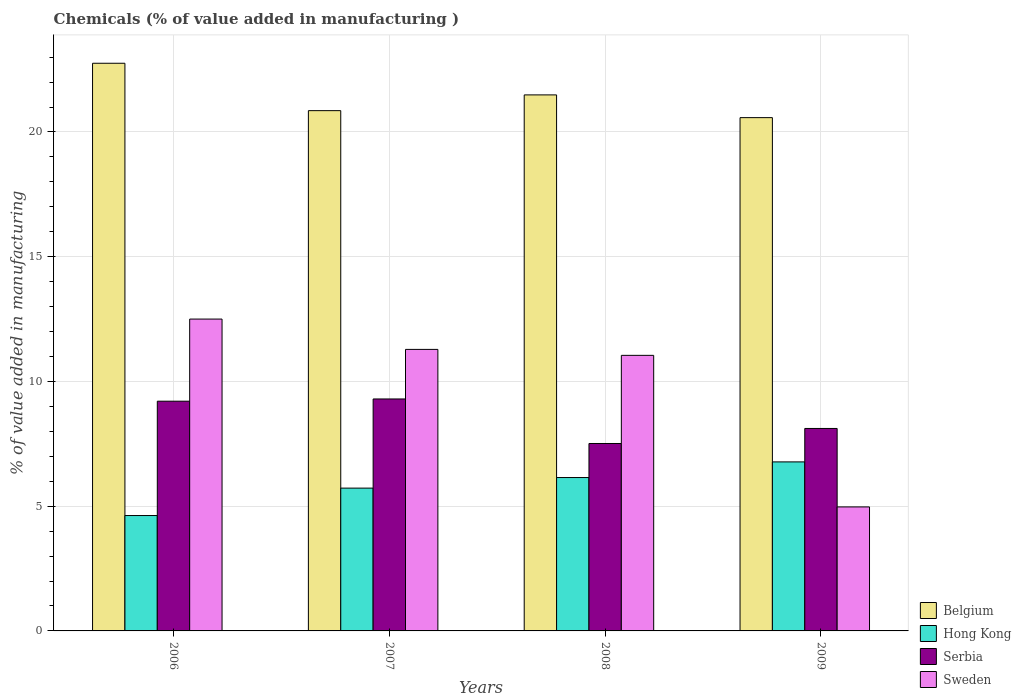How many groups of bars are there?
Provide a short and direct response. 4. Are the number of bars on each tick of the X-axis equal?
Your response must be concise. Yes. How many bars are there on the 4th tick from the left?
Your answer should be compact. 4. How many bars are there on the 2nd tick from the right?
Ensure brevity in your answer.  4. What is the label of the 2nd group of bars from the left?
Provide a succinct answer. 2007. In how many cases, is the number of bars for a given year not equal to the number of legend labels?
Your answer should be compact. 0. What is the value added in manufacturing chemicals in Sweden in 2007?
Your answer should be compact. 11.29. Across all years, what is the maximum value added in manufacturing chemicals in Sweden?
Offer a very short reply. 12.5. Across all years, what is the minimum value added in manufacturing chemicals in Belgium?
Keep it short and to the point. 20.58. In which year was the value added in manufacturing chemicals in Belgium maximum?
Keep it short and to the point. 2006. In which year was the value added in manufacturing chemicals in Serbia minimum?
Provide a short and direct response. 2008. What is the total value added in manufacturing chemicals in Sweden in the graph?
Give a very brief answer. 39.8. What is the difference between the value added in manufacturing chemicals in Sweden in 2006 and that in 2007?
Your response must be concise. 1.22. What is the difference between the value added in manufacturing chemicals in Hong Kong in 2007 and the value added in manufacturing chemicals in Serbia in 2009?
Your response must be concise. -2.39. What is the average value added in manufacturing chemicals in Sweden per year?
Your answer should be very brief. 9.95. In the year 2009, what is the difference between the value added in manufacturing chemicals in Serbia and value added in manufacturing chemicals in Sweden?
Your answer should be very brief. 3.14. In how many years, is the value added in manufacturing chemicals in Belgium greater than 10 %?
Offer a terse response. 4. What is the ratio of the value added in manufacturing chemicals in Hong Kong in 2006 to that in 2009?
Make the answer very short. 0.68. Is the value added in manufacturing chemicals in Serbia in 2006 less than that in 2008?
Your answer should be compact. No. Is the difference between the value added in manufacturing chemicals in Serbia in 2006 and 2009 greater than the difference between the value added in manufacturing chemicals in Sweden in 2006 and 2009?
Offer a very short reply. No. What is the difference between the highest and the second highest value added in manufacturing chemicals in Serbia?
Your answer should be compact. 0.09. What is the difference between the highest and the lowest value added in manufacturing chemicals in Belgium?
Offer a terse response. 2.18. Is the sum of the value added in manufacturing chemicals in Serbia in 2006 and 2008 greater than the maximum value added in manufacturing chemicals in Hong Kong across all years?
Keep it short and to the point. Yes. Is it the case that in every year, the sum of the value added in manufacturing chemicals in Serbia and value added in manufacturing chemicals in Sweden is greater than the sum of value added in manufacturing chemicals in Hong Kong and value added in manufacturing chemicals in Belgium?
Your answer should be compact. No. What does the 3rd bar from the left in 2009 represents?
Your response must be concise. Serbia. What does the 3rd bar from the right in 2009 represents?
Provide a short and direct response. Hong Kong. How many bars are there?
Make the answer very short. 16. What is the difference between two consecutive major ticks on the Y-axis?
Give a very brief answer. 5. Are the values on the major ticks of Y-axis written in scientific E-notation?
Make the answer very short. No. How are the legend labels stacked?
Offer a very short reply. Vertical. What is the title of the graph?
Your response must be concise. Chemicals (% of value added in manufacturing ). Does "Kenya" appear as one of the legend labels in the graph?
Provide a short and direct response. No. What is the label or title of the Y-axis?
Your answer should be very brief. % of value added in manufacturing. What is the % of value added in manufacturing in Belgium in 2006?
Offer a terse response. 22.76. What is the % of value added in manufacturing of Hong Kong in 2006?
Offer a very short reply. 4.63. What is the % of value added in manufacturing in Serbia in 2006?
Your response must be concise. 9.21. What is the % of value added in manufacturing in Sweden in 2006?
Your response must be concise. 12.5. What is the % of value added in manufacturing in Belgium in 2007?
Keep it short and to the point. 20.86. What is the % of value added in manufacturing of Hong Kong in 2007?
Give a very brief answer. 5.72. What is the % of value added in manufacturing in Serbia in 2007?
Provide a short and direct response. 9.3. What is the % of value added in manufacturing of Sweden in 2007?
Provide a succinct answer. 11.29. What is the % of value added in manufacturing of Belgium in 2008?
Provide a short and direct response. 21.49. What is the % of value added in manufacturing in Hong Kong in 2008?
Offer a very short reply. 6.15. What is the % of value added in manufacturing of Serbia in 2008?
Offer a terse response. 7.51. What is the % of value added in manufacturing of Sweden in 2008?
Your response must be concise. 11.05. What is the % of value added in manufacturing in Belgium in 2009?
Give a very brief answer. 20.58. What is the % of value added in manufacturing of Hong Kong in 2009?
Ensure brevity in your answer.  6.78. What is the % of value added in manufacturing of Serbia in 2009?
Offer a terse response. 8.12. What is the % of value added in manufacturing in Sweden in 2009?
Make the answer very short. 4.97. Across all years, what is the maximum % of value added in manufacturing in Belgium?
Provide a succinct answer. 22.76. Across all years, what is the maximum % of value added in manufacturing of Hong Kong?
Offer a very short reply. 6.78. Across all years, what is the maximum % of value added in manufacturing in Serbia?
Provide a short and direct response. 9.3. Across all years, what is the maximum % of value added in manufacturing in Sweden?
Give a very brief answer. 12.5. Across all years, what is the minimum % of value added in manufacturing of Belgium?
Provide a succinct answer. 20.58. Across all years, what is the minimum % of value added in manufacturing in Hong Kong?
Your answer should be compact. 4.63. Across all years, what is the minimum % of value added in manufacturing of Serbia?
Your answer should be compact. 7.51. Across all years, what is the minimum % of value added in manufacturing of Sweden?
Your answer should be very brief. 4.97. What is the total % of value added in manufacturing of Belgium in the graph?
Your response must be concise. 85.67. What is the total % of value added in manufacturing in Hong Kong in the graph?
Provide a succinct answer. 23.27. What is the total % of value added in manufacturing in Serbia in the graph?
Give a very brief answer. 34.14. What is the total % of value added in manufacturing in Sweden in the graph?
Keep it short and to the point. 39.8. What is the difference between the % of value added in manufacturing in Belgium in 2006 and that in 2007?
Ensure brevity in your answer.  1.9. What is the difference between the % of value added in manufacturing in Hong Kong in 2006 and that in 2007?
Make the answer very short. -1.1. What is the difference between the % of value added in manufacturing in Serbia in 2006 and that in 2007?
Make the answer very short. -0.09. What is the difference between the % of value added in manufacturing of Sweden in 2006 and that in 2007?
Provide a succinct answer. 1.22. What is the difference between the % of value added in manufacturing of Belgium in 2006 and that in 2008?
Keep it short and to the point. 1.27. What is the difference between the % of value added in manufacturing in Hong Kong in 2006 and that in 2008?
Keep it short and to the point. -1.52. What is the difference between the % of value added in manufacturing of Serbia in 2006 and that in 2008?
Keep it short and to the point. 1.7. What is the difference between the % of value added in manufacturing of Sweden in 2006 and that in 2008?
Keep it short and to the point. 1.45. What is the difference between the % of value added in manufacturing in Belgium in 2006 and that in 2009?
Offer a very short reply. 2.18. What is the difference between the % of value added in manufacturing of Hong Kong in 2006 and that in 2009?
Your response must be concise. -2.15. What is the difference between the % of value added in manufacturing in Serbia in 2006 and that in 2009?
Give a very brief answer. 1.09. What is the difference between the % of value added in manufacturing of Sweden in 2006 and that in 2009?
Ensure brevity in your answer.  7.53. What is the difference between the % of value added in manufacturing in Belgium in 2007 and that in 2008?
Provide a short and direct response. -0.63. What is the difference between the % of value added in manufacturing in Hong Kong in 2007 and that in 2008?
Offer a very short reply. -0.42. What is the difference between the % of value added in manufacturing of Serbia in 2007 and that in 2008?
Provide a short and direct response. 1.78. What is the difference between the % of value added in manufacturing in Sweden in 2007 and that in 2008?
Keep it short and to the point. 0.24. What is the difference between the % of value added in manufacturing in Belgium in 2007 and that in 2009?
Your response must be concise. 0.28. What is the difference between the % of value added in manufacturing of Hong Kong in 2007 and that in 2009?
Your response must be concise. -1.05. What is the difference between the % of value added in manufacturing in Serbia in 2007 and that in 2009?
Provide a succinct answer. 1.18. What is the difference between the % of value added in manufacturing of Sweden in 2007 and that in 2009?
Give a very brief answer. 6.31. What is the difference between the % of value added in manufacturing of Belgium in 2008 and that in 2009?
Offer a terse response. 0.91. What is the difference between the % of value added in manufacturing of Hong Kong in 2008 and that in 2009?
Make the answer very short. -0.63. What is the difference between the % of value added in manufacturing in Serbia in 2008 and that in 2009?
Your answer should be very brief. -0.6. What is the difference between the % of value added in manufacturing of Sweden in 2008 and that in 2009?
Provide a succinct answer. 6.08. What is the difference between the % of value added in manufacturing in Belgium in 2006 and the % of value added in manufacturing in Hong Kong in 2007?
Your answer should be very brief. 17.03. What is the difference between the % of value added in manufacturing of Belgium in 2006 and the % of value added in manufacturing of Serbia in 2007?
Provide a succinct answer. 13.46. What is the difference between the % of value added in manufacturing of Belgium in 2006 and the % of value added in manufacturing of Sweden in 2007?
Keep it short and to the point. 11.47. What is the difference between the % of value added in manufacturing of Hong Kong in 2006 and the % of value added in manufacturing of Serbia in 2007?
Keep it short and to the point. -4.67. What is the difference between the % of value added in manufacturing of Hong Kong in 2006 and the % of value added in manufacturing of Sweden in 2007?
Your response must be concise. -6.66. What is the difference between the % of value added in manufacturing of Serbia in 2006 and the % of value added in manufacturing of Sweden in 2007?
Provide a succinct answer. -2.08. What is the difference between the % of value added in manufacturing in Belgium in 2006 and the % of value added in manufacturing in Hong Kong in 2008?
Offer a terse response. 16.61. What is the difference between the % of value added in manufacturing in Belgium in 2006 and the % of value added in manufacturing in Serbia in 2008?
Keep it short and to the point. 15.24. What is the difference between the % of value added in manufacturing in Belgium in 2006 and the % of value added in manufacturing in Sweden in 2008?
Keep it short and to the point. 11.71. What is the difference between the % of value added in manufacturing in Hong Kong in 2006 and the % of value added in manufacturing in Serbia in 2008?
Your answer should be very brief. -2.89. What is the difference between the % of value added in manufacturing in Hong Kong in 2006 and the % of value added in manufacturing in Sweden in 2008?
Offer a very short reply. -6.42. What is the difference between the % of value added in manufacturing in Serbia in 2006 and the % of value added in manufacturing in Sweden in 2008?
Provide a succinct answer. -1.84. What is the difference between the % of value added in manufacturing in Belgium in 2006 and the % of value added in manufacturing in Hong Kong in 2009?
Your answer should be very brief. 15.98. What is the difference between the % of value added in manufacturing of Belgium in 2006 and the % of value added in manufacturing of Serbia in 2009?
Offer a terse response. 14.64. What is the difference between the % of value added in manufacturing of Belgium in 2006 and the % of value added in manufacturing of Sweden in 2009?
Ensure brevity in your answer.  17.78. What is the difference between the % of value added in manufacturing of Hong Kong in 2006 and the % of value added in manufacturing of Serbia in 2009?
Your response must be concise. -3.49. What is the difference between the % of value added in manufacturing in Hong Kong in 2006 and the % of value added in manufacturing in Sweden in 2009?
Ensure brevity in your answer.  -0.35. What is the difference between the % of value added in manufacturing in Serbia in 2006 and the % of value added in manufacturing in Sweden in 2009?
Your answer should be very brief. 4.24. What is the difference between the % of value added in manufacturing of Belgium in 2007 and the % of value added in manufacturing of Hong Kong in 2008?
Offer a terse response. 14.71. What is the difference between the % of value added in manufacturing in Belgium in 2007 and the % of value added in manufacturing in Serbia in 2008?
Your answer should be very brief. 13.34. What is the difference between the % of value added in manufacturing of Belgium in 2007 and the % of value added in manufacturing of Sweden in 2008?
Keep it short and to the point. 9.81. What is the difference between the % of value added in manufacturing in Hong Kong in 2007 and the % of value added in manufacturing in Serbia in 2008?
Your response must be concise. -1.79. What is the difference between the % of value added in manufacturing in Hong Kong in 2007 and the % of value added in manufacturing in Sweden in 2008?
Ensure brevity in your answer.  -5.32. What is the difference between the % of value added in manufacturing of Serbia in 2007 and the % of value added in manufacturing of Sweden in 2008?
Provide a succinct answer. -1.75. What is the difference between the % of value added in manufacturing in Belgium in 2007 and the % of value added in manufacturing in Hong Kong in 2009?
Offer a terse response. 14.08. What is the difference between the % of value added in manufacturing of Belgium in 2007 and the % of value added in manufacturing of Serbia in 2009?
Make the answer very short. 12.74. What is the difference between the % of value added in manufacturing in Belgium in 2007 and the % of value added in manufacturing in Sweden in 2009?
Your answer should be very brief. 15.88. What is the difference between the % of value added in manufacturing in Hong Kong in 2007 and the % of value added in manufacturing in Serbia in 2009?
Your response must be concise. -2.39. What is the difference between the % of value added in manufacturing in Hong Kong in 2007 and the % of value added in manufacturing in Sweden in 2009?
Offer a terse response. 0.75. What is the difference between the % of value added in manufacturing of Serbia in 2007 and the % of value added in manufacturing of Sweden in 2009?
Your answer should be very brief. 4.33. What is the difference between the % of value added in manufacturing in Belgium in 2008 and the % of value added in manufacturing in Hong Kong in 2009?
Give a very brief answer. 14.71. What is the difference between the % of value added in manufacturing of Belgium in 2008 and the % of value added in manufacturing of Serbia in 2009?
Offer a very short reply. 13.37. What is the difference between the % of value added in manufacturing of Belgium in 2008 and the % of value added in manufacturing of Sweden in 2009?
Keep it short and to the point. 16.52. What is the difference between the % of value added in manufacturing of Hong Kong in 2008 and the % of value added in manufacturing of Serbia in 2009?
Provide a short and direct response. -1.97. What is the difference between the % of value added in manufacturing in Hong Kong in 2008 and the % of value added in manufacturing in Sweden in 2009?
Provide a succinct answer. 1.18. What is the difference between the % of value added in manufacturing in Serbia in 2008 and the % of value added in manufacturing in Sweden in 2009?
Make the answer very short. 2.54. What is the average % of value added in manufacturing of Belgium per year?
Your answer should be very brief. 21.42. What is the average % of value added in manufacturing in Hong Kong per year?
Keep it short and to the point. 5.82. What is the average % of value added in manufacturing in Serbia per year?
Make the answer very short. 8.53. What is the average % of value added in manufacturing of Sweden per year?
Your answer should be compact. 9.95. In the year 2006, what is the difference between the % of value added in manufacturing of Belgium and % of value added in manufacturing of Hong Kong?
Your answer should be very brief. 18.13. In the year 2006, what is the difference between the % of value added in manufacturing of Belgium and % of value added in manufacturing of Serbia?
Your answer should be compact. 13.55. In the year 2006, what is the difference between the % of value added in manufacturing of Belgium and % of value added in manufacturing of Sweden?
Give a very brief answer. 10.25. In the year 2006, what is the difference between the % of value added in manufacturing of Hong Kong and % of value added in manufacturing of Serbia?
Your answer should be compact. -4.58. In the year 2006, what is the difference between the % of value added in manufacturing in Hong Kong and % of value added in manufacturing in Sweden?
Your answer should be very brief. -7.88. In the year 2006, what is the difference between the % of value added in manufacturing of Serbia and % of value added in manufacturing of Sweden?
Your answer should be compact. -3.29. In the year 2007, what is the difference between the % of value added in manufacturing of Belgium and % of value added in manufacturing of Hong Kong?
Your response must be concise. 15.13. In the year 2007, what is the difference between the % of value added in manufacturing of Belgium and % of value added in manufacturing of Serbia?
Your answer should be very brief. 11.56. In the year 2007, what is the difference between the % of value added in manufacturing of Belgium and % of value added in manufacturing of Sweden?
Your answer should be very brief. 9.57. In the year 2007, what is the difference between the % of value added in manufacturing of Hong Kong and % of value added in manufacturing of Serbia?
Ensure brevity in your answer.  -3.57. In the year 2007, what is the difference between the % of value added in manufacturing of Hong Kong and % of value added in manufacturing of Sweden?
Offer a very short reply. -5.56. In the year 2007, what is the difference between the % of value added in manufacturing in Serbia and % of value added in manufacturing in Sweden?
Your answer should be compact. -1.99. In the year 2008, what is the difference between the % of value added in manufacturing of Belgium and % of value added in manufacturing of Hong Kong?
Your response must be concise. 15.34. In the year 2008, what is the difference between the % of value added in manufacturing of Belgium and % of value added in manufacturing of Serbia?
Offer a terse response. 13.97. In the year 2008, what is the difference between the % of value added in manufacturing in Belgium and % of value added in manufacturing in Sweden?
Make the answer very short. 10.44. In the year 2008, what is the difference between the % of value added in manufacturing of Hong Kong and % of value added in manufacturing of Serbia?
Your answer should be very brief. -1.36. In the year 2008, what is the difference between the % of value added in manufacturing in Hong Kong and % of value added in manufacturing in Sweden?
Make the answer very short. -4.9. In the year 2008, what is the difference between the % of value added in manufacturing in Serbia and % of value added in manufacturing in Sweden?
Your answer should be very brief. -3.53. In the year 2009, what is the difference between the % of value added in manufacturing in Belgium and % of value added in manufacturing in Hong Kong?
Your answer should be very brief. 13.8. In the year 2009, what is the difference between the % of value added in manufacturing of Belgium and % of value added in manufacturing of Serbia?
Provide a succinct answer. 12.46. In the year 2009, what is the difference between the % of value added in manufacturing in Belgium and % of value added in manufacturing in Sweden?
Your answer should be compact. 15.6. In the year 2009, what is the difference between the % of value added in manufacturing in Hong Kong and % of value added in manufacturing in Serbia?
Your answer should be very brief. -1.34. In the year 2009, what is the difference between the % of value added in manufacturing of Hong Kong and % of value added in manufacturing of Sweden?
Ensure brevity in your answer.  1.8. In the year 2009, what is the difference between the % of value added in manufacturing of Serbia and % of value added in manufacturing of Sweden?
Give a very brief answer. 3.14. What is the ratio of the % of value added in manufacturing in Belgium in 2006 to that in 2007?
Offer a very short reply. 1.09. What is the ratio of the % of value added in manufacturing of Hong Kong in 2006 to that in 2007?
Your answer should be compact. 0.81. What is the ratio of the % of value added in manufacturing in Sweden in 2006 to that in 2007?
Provide a succinct answer. 1.11. What is the ratio of the % of value added in manufacturing of Belgium in 2006 to that in 2008?
Keep it short and to the point. 1.06. What is the ratio of the % of value added in manufacturing in Hong Kong in 2006 to that in 2008?
Your response must be concise. 0.75. What is the ratio of the % of value added in manufacturing of Serbia in 2006 to that in 2008?
Ensure brevity in your answer.  1.23. What is the ratio of the % of value added in manufacturing of Sweden in 2006 to that in 2008?
Make the answer very short. 1.13. What is the ratio of the % of value added in manufacturing in Belgium in 2006 to that in 2009?
Ensure brevity in your answer.  1.11. What is the ratio of the % of value added in manufacturing in Hong Kong in 2006 to that in 2009?
Give a very brief answer. 0.68. What is the ratio of the % of value added in manufacturing of Serbia in 2006 to that in 2009?
Your response must be concise. 1.13. What is the ratio of the % of value added in manufacturing of Sweden in 2006 to that in 2009?
Offer a very short reply. 2.51. What is the ratio of the % of value added in manufacturing in Belgium in 2007 to that in 2008?
Your response must be concise. 0.97. What is the ratio of the % of value added in manufacturing in Hong Kong in 2007 to that in 2008?
Your response must be concise. 0.93. What is the ratio of the % of value added in manufacturing of Serbia in 2007 to that in 2008?
Offer a very short reply. 1.24. What is the ratio of the % of value added in manufacturing in Sweden in 2007 to that in 2008?
Offer a very short reply. 1.02. What is the ratio of the % of value added in manufacturing in Belgium in 2007 to that in 2009?
Offer a terse response. 1.01. What is the ratio of the % of value added in manufacturing in Hong Kong in 2007 to that in 2009?
Offer a terse response. 0.84. What is the ratio of the % of value added in manufacturing in Serbia in 2007 to that in 2009?
Offer a very short reply. 1.15. What is the ratio of the % of value added in manufacturing of Sweden in 2007 to that in 2009?
Your answer should be very brief. 2.27. What is the ratio of the % of value added in manufacturing in Belgium in 2008 to that in 2009?
Provide a succinct answer. 1.04. What is the ratio of the % of value added in manufacturing in Hong Kong in 2008 to that in 2009?
Offer a terse response. 0.91. What is the ratio of the % of value added in manufacturing of Serbia in 2008 to that in 2009?
Your response must be concise. 0.93. What is the ratio of the % of value added in manufacturing in Sweden in 2008 to that in 2009?
Your response must be concise. 2.22. What is the difference between the highest and the second highest % of value added in manufacturing in Belgium?
Keep it short and to the point. 1.27. What is the difference between the highest and the second highest % of value added in manufacturing of Hong Kong?
Keep it short and to the point. 0.63. What is the difference between the highest and the second highest % of value added in manufacturing in Serbia?
Offer a very short reply. 0.09. What is the difference between the highest and the second highest % of value added in manufacturing of Sweden?
Keep it short and to the point. 1.22. What is the difference between the highest and the lowest % of value added in manufacturing of Belgium?
Give a very brief answer. 2.18. What is the difference between the highest and the lowest % of value added in manufacturing of Hong Kong?
Offer a very short reply. 2.15. What is the difference between the highest and the lowest % of value added in manufacturing in Serbia?
Your answer should be very brief. 1.78. What is the difference between the highest and the lowest % of value added in manufacturing in Sweden?
Keep it short and to the point. 7.53. 